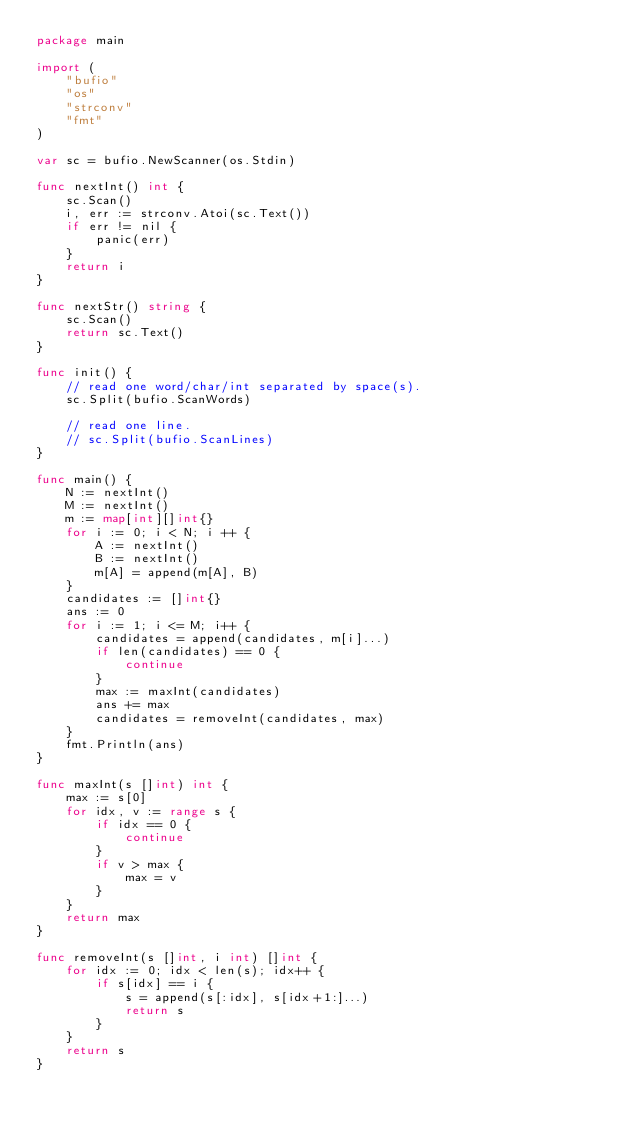Convert code to text. <code><loc_0><loc_0><loc_500><loc_500><_Go_>package main

import (
	"bufio"
	"os"
	"strconv"
	"fmt"
)

var sc = bufio.NewScanner(os.Stdin)

func nextInt() int {
	sc.Scan()
	i, err := strconv.Atoi(sc.Text())
	if err != nil {
		panic(err)
	}
	return i
}

func nextStr() string {
	sc.Scan()
	return sc.Text()
}

func init() {
	// read one word/char/int separated by space(s).
	sc.Split(bufio.ScanWords)

	// read one line.
	// sc.Split(bufio.ScanLines)
}

func main() {
	N := nextInt()
	M := nextInt()
	m := map[int][]int{}
	for i := 0; i < N; i ++ {
		A := nextInt()
		B := nextInt()
		m[A] = append(m[A], B)
	}
	candidates := []int{}
	ans := 0
	for i := 1; i <= M; i++ {
		candidates = append(candidates, m[i]...)
		if len(candidates) == 0 {
			continue
		}
		max := maxInt(candidates)
		ans += max
		candidates = removeInt(candidates, max)
	}
	fmt.Println(ans)
}

func maxInt(s []int) int {
	max := s[0]
	for idx, v := range s {
		if idx == 0 {
			continue
		}
		if v > max {
			max = v
		}
	}
	return max
}

func removeInt(s []int, i int) []int {
	for idx := 0; idx < len(s); idx++ {
		if s[idx] == i {
			s = append(s[:idx], s[idx+1:]...)
			return s
		}
	}
	return s
}</code> 